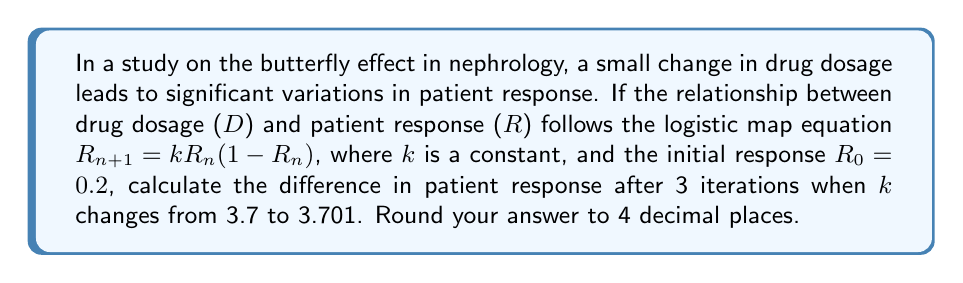Provide a solution to this math problem. Let's approach this step-by-step:

1) We need to calculate R3 for both k = 3.7 and k = 3.701.

2) For k = 3.7:
   $R_1 = 3.7 * 0.2 * (1-0.2) = 0.592$
   $R_2 = 3.7 * 0.592 * (1-0.592) = 0.8913478656$
   $R_3 = 3.7 * 0.8913478656 * (1-0.8913478656) = 0.3582691145$

3) For k = 3.701:
   $R_1 = 3.701 * 0.2 * (1-0.2) = 0.59216$
   $R_2 = 3.701 * 0.59216 * (1-0.59216) = 0.8920769985$
   $R_3 = 3.701 * 0.8920769985 * (1-0.8920769985) = 0.3560260066$

4) The difference in R3 values:
   $|0.3582691145 - 0.3560260066| = 0.0022431079$

5) Rounding to 4 decimal places: 0.0022

This demonstrates how a small change in the parameter k (0.001) can lead to a noticeable difference in the outcome after just a few iterations, illustrating the butterfly effect in drug dosage and patient response.
Answer: 0.0022 